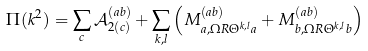<formula> <loc_0><loc_0><loc_500><loc_500>\Pi ( k ^ { 2 } ) = \sum _ { c } \mathcal { A } _ { 2 ( c ) } ^ { ( a b ) } + \sum _ { k , l } \left ( M _ { a , \Omega R \Theta ^ { k , l } a } ^ { ( a b ) } + M _ { b , \Omega R \Theta ^ { k , l } b } ^ { ( a b ) } \right )</formula> 